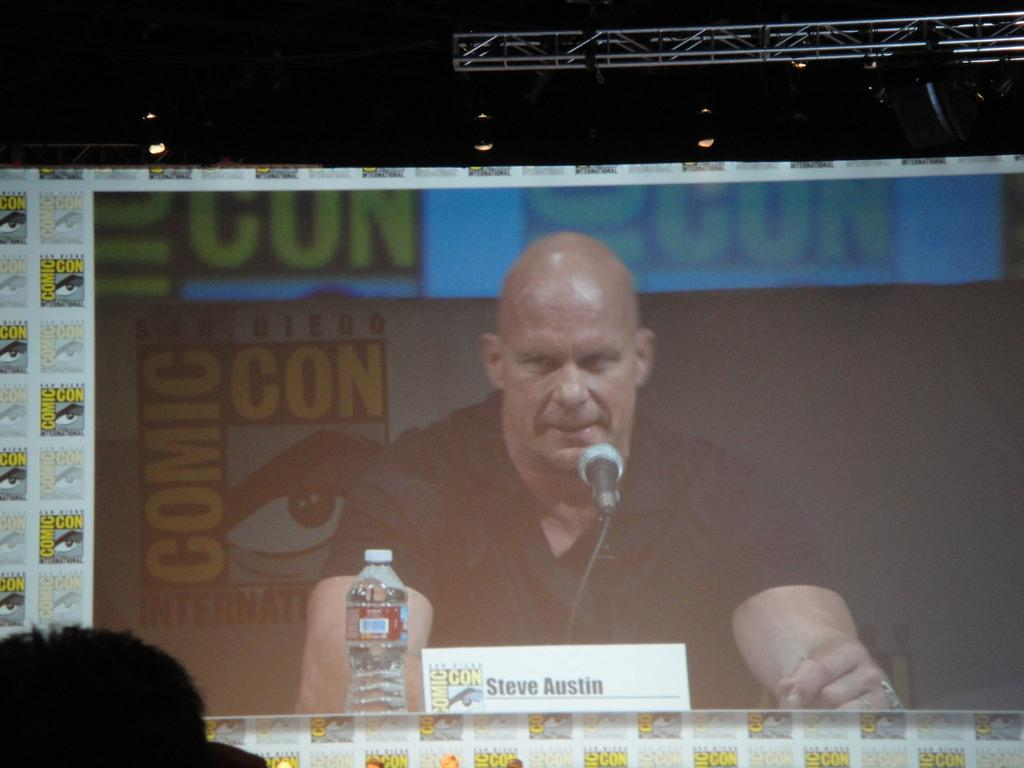What is the person in the image doing? The person is sitting on a chair in the image. What object can be seen next to the person? There is a table in the image. What is placed on the table? There is a name board and a bottle on the table. What type of branch is the person holding in the image? There is no branch present in the image. How does the person's body appear in the image? The person's body is not described in the provided facts, but we can see that they are sitting on a chair. What is the condition of the person's heart in the image? There is no information about the person's heart in the provided facts, and we cannot determine their heart condition from the image. 